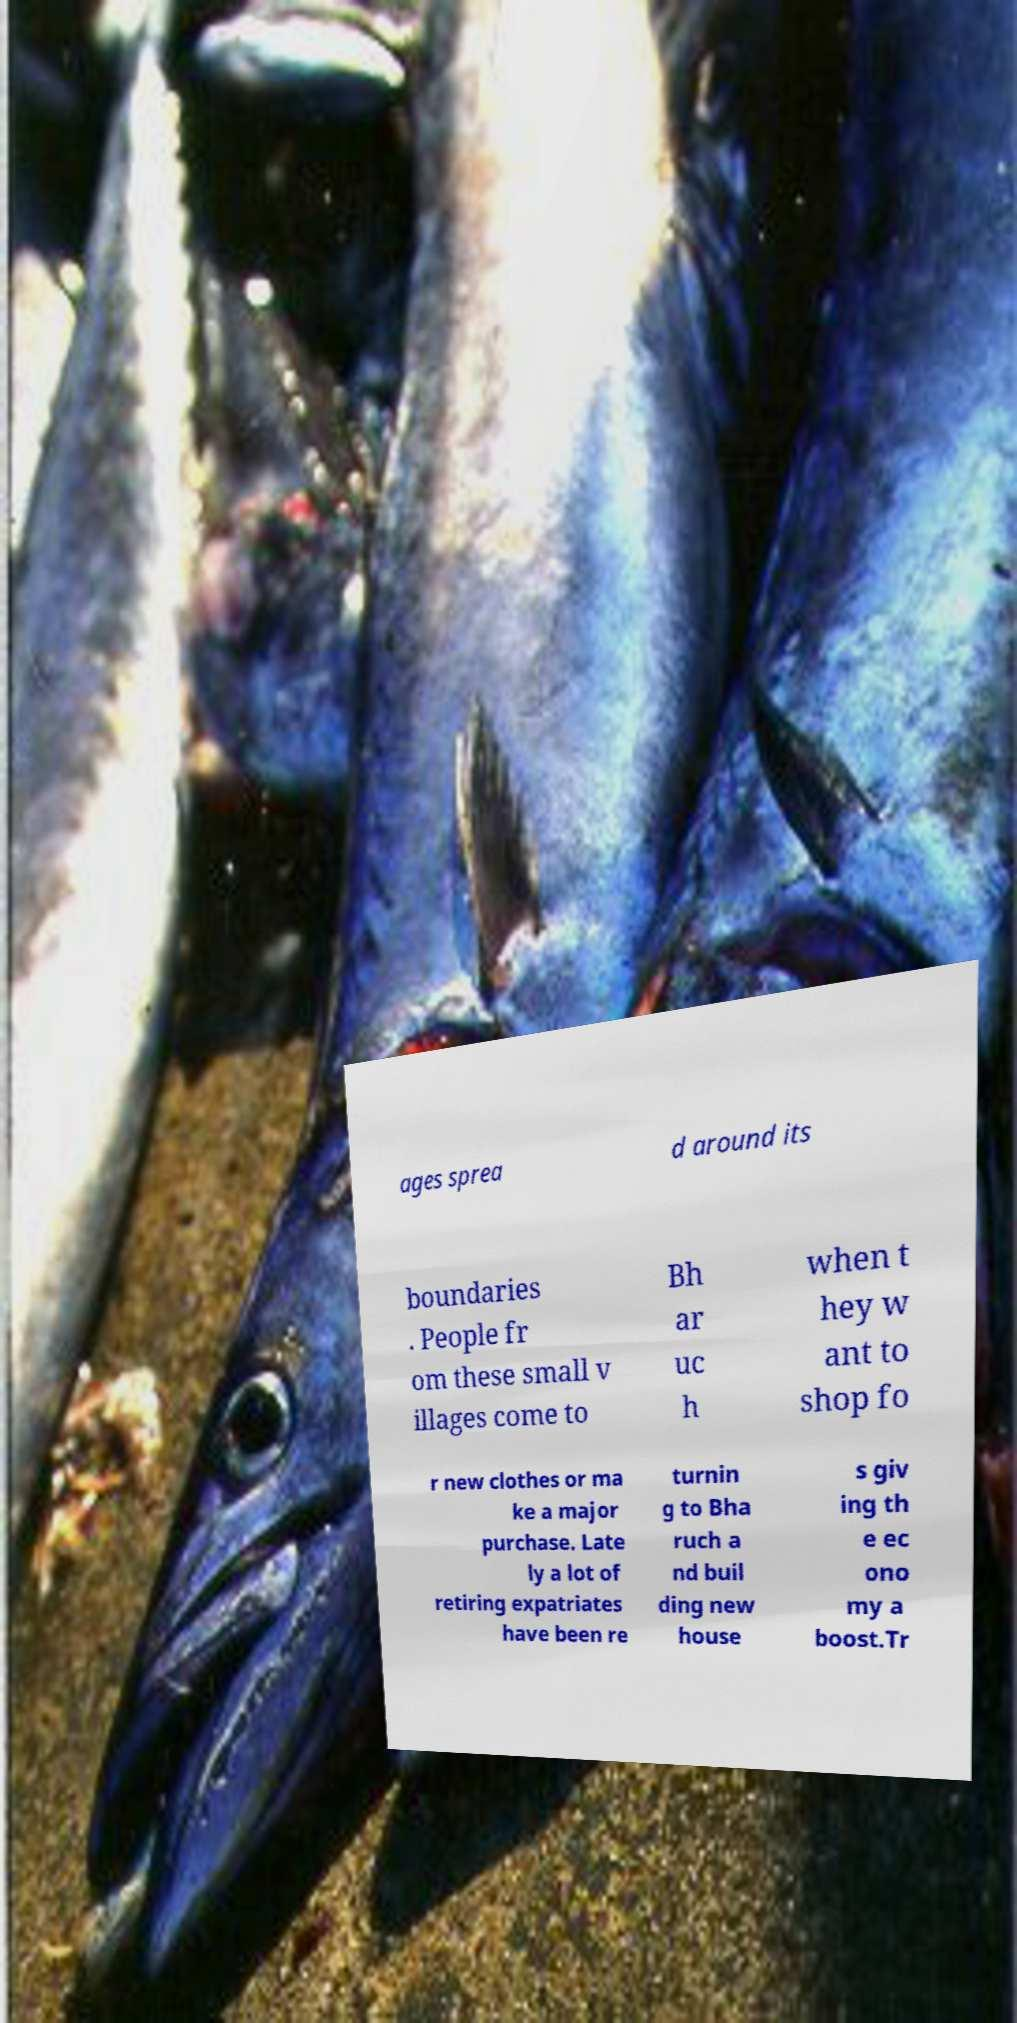Can you read and provide the text displayed in the image?This photo seems to have some interesting text. Can you extract and type it out for me? ages sprea d around its boundaries . People fr om these small v illages come to Bh ar uc h when t hey w ant to shop fo r new clothes or ma ke a major purchase. Late ly a lot of retiring expatriates have been re turnin g to Bha ruch a nd buil ding new house s giv ing th e ec ono my a boost.Tr 